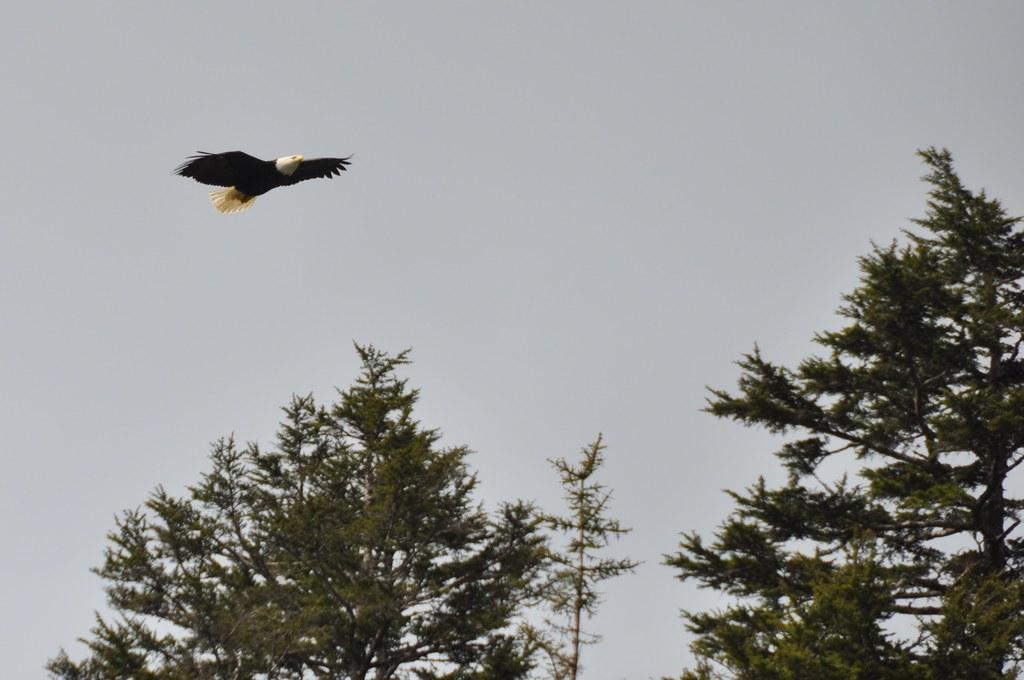What animal is featured in the image? There is an eagle in the image. What is the eagle doing in the image? The eagle is flying in the air. What can be seen in the background of the image? There are trees and the sky visible in the background of the image. What grade does the eagle receive for its performance in the image? There is no grading system or performance evaluation for the eagle in the image; it is simply flying. 